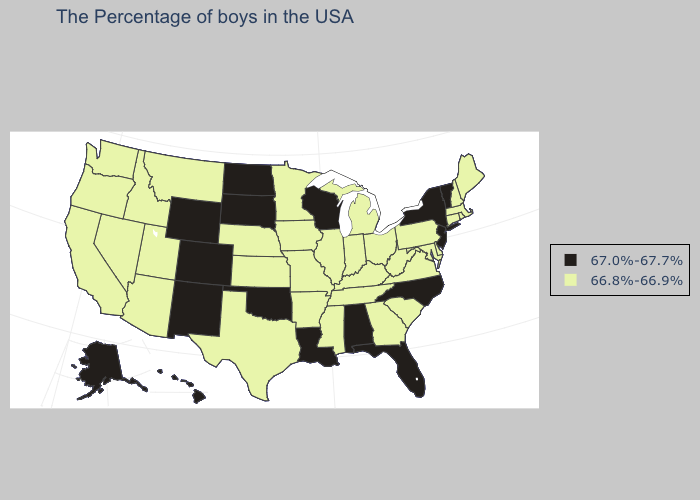Name the states that have a value in the range 66.8%-66.9%?
Answer briefly. Maine, Massachusetts, Rhode Island, New Hampshire, Connecticut, Delaware, Maryland, Pennsylvania, Virginia, South Carolina, West Virginia, Ohio, Georgia, Michigan, Kentucky, Indiana, Tennessee, Illinois, Mississippi, Missouri, Arkansas, Minnesota, Iowa, Kansas, Nebraska, Texas, Utah, Montana, Arizona, Idaho, Nevada, California, Washington, Oregon. Name the states that have a value in the range 66.8%-66.9%?
Be succinct. Maine, Massachusetts, Rhode Island, New Hampshire, Connecticut, Delaware, Maryland, Pennsylvania, Virginia, South Carolina, West Virginia, Ohio, Georgia, Michigan, Kentucky, Indiana, Tennessee, Illinois, Mississippi, Missouri, Arkansas, Minnesota, Iowa, Kansas, Nebraska, Texas, Utah, Montana, Arizona, Idaho, Nevada, California, Washington, Oregon. What is the value of Michigan?
Concise answer only. 66.8%-66.9%. Does New Jersey have the highest value in the Northeast?
Short answer required. Yes. Among the states that border Iowa , does Minnesota have the lowest value?
Concise answer only. Yes. What is the lowest value in the USA?
Quick response, please. 66.8%-66.9%. Name the states that have a value in the range 66.8%-66.9%?
Be succinct. Maine, Massachusetts, Rhode Island, New Hampshire, Connecticut, Delaware, Maryland, Pennsylvania, Virginia, South Carolina, West Virginia, Ohio, Georgia, Michigan, Kentucky, Indiana, Tennessee, Illinois, Mississippi, Missouri, Arkansas, Minnesota, Iowa, Kansas, Nebraska, Texas, Utah, Montana, Arizona, Idaho, Nevada, California, Washington, Oregon. Does South Carolina have the lowest value in the South?
Short answer required. Yes. Does New Hampshire have the highest value in the Northeast?
Answer briefly. No. What is the value of Georgia?
Answer briefly. 66.8%-66.9%. What is the value of Utah?
Answer briefly. 66.8%-66.9%. Which states have the lowest value in the Northeast?
Concise answer only. Maine, Massachusetts, Rhode Island, New Hampshire, Connecticut, Pennsylvania. Name the states that have a value in the range 66.8%-66.9%?
Answer briefly. Maine, Massachusetts, Rhode Island, New Hampshire, Connecticut, Delaware, Maryland, Pennsylvania, Virginia, South Carolina, West Virginia, Ohio, Georgia, Michigan, Kentucky, Indiana, Tennessee, Illinois, Mississippi, Missouri, Arkansas, Minnesota, Iowa, Kansas, Nebraska, Texas, Utah, Montana, Arizona, Idaho, Nevada, California, Washington, Oregon. Does New Mexico have the lowest value in the West?
Keep it brief. No. Name the states that have a value in the range 67.0%-67.7%?
Answer briefly. Vermont, New York, New Jersey, North Carolina, Florida, Alabama, Wisconsin, Louisiana, Oklahoma, South Dakota, North Dakota, Wyoming, Colorado, New Mexico, Alaska, Hawaii. 